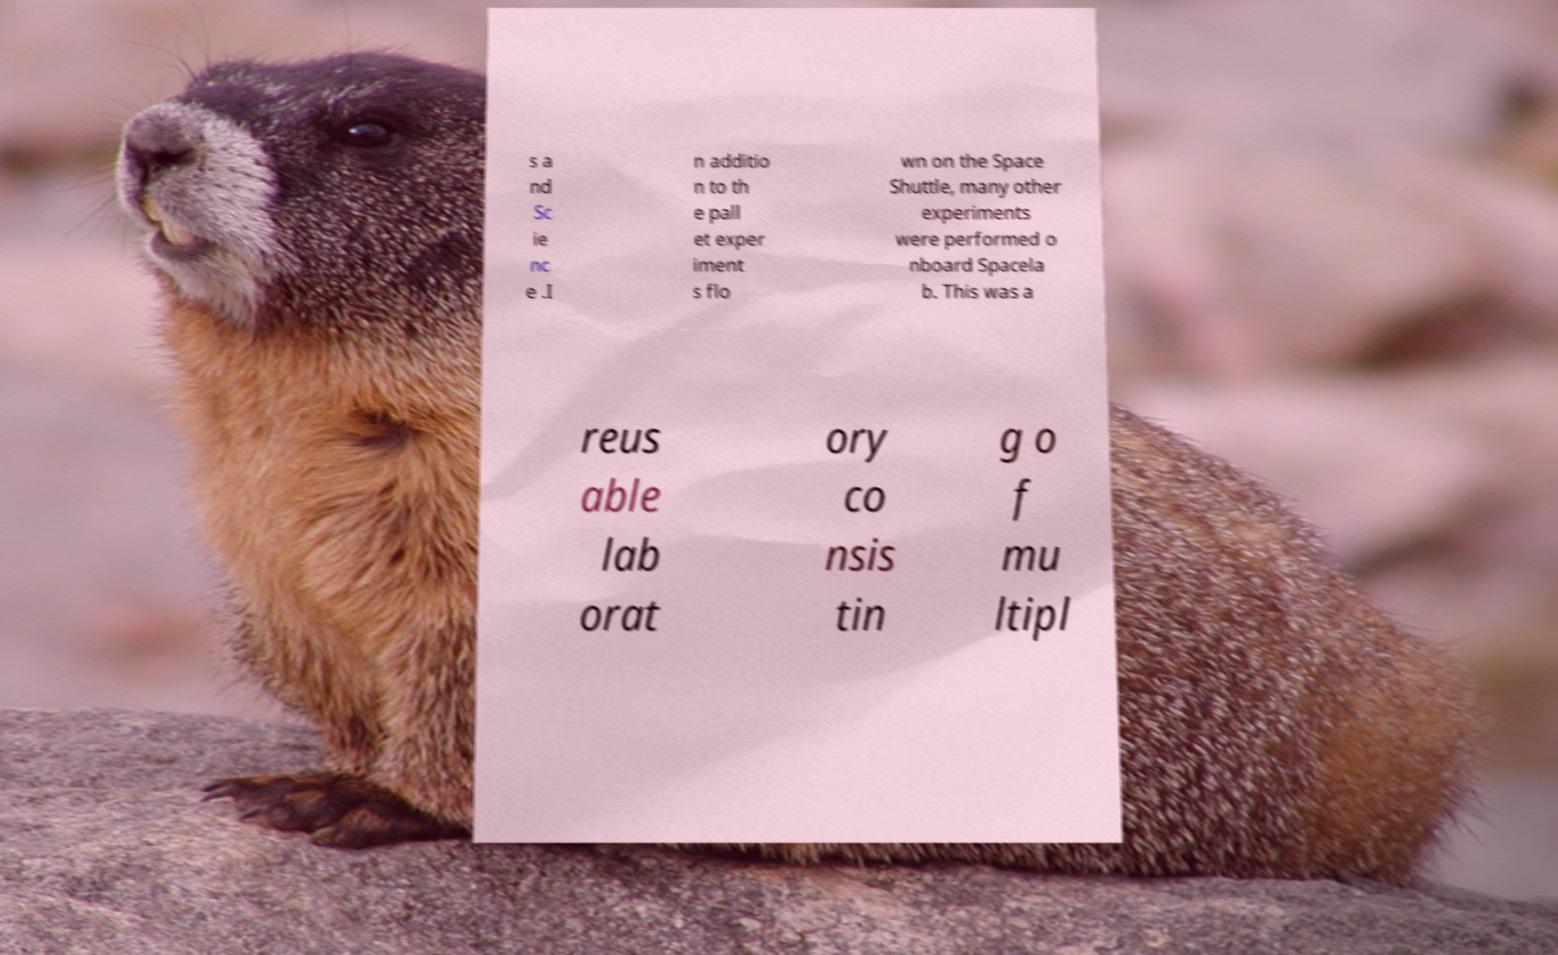For documentation purposes, I need the text within this image transcribed. Could you provide that? s a nd Sc ie nc e .I n additio n to th e pall et exper iment s flo wn on the Space Shuttle, many other experiments were performed o nboard Spacela b. This was a reus able lab orat ory co nsis tin g o f mu ltipl 